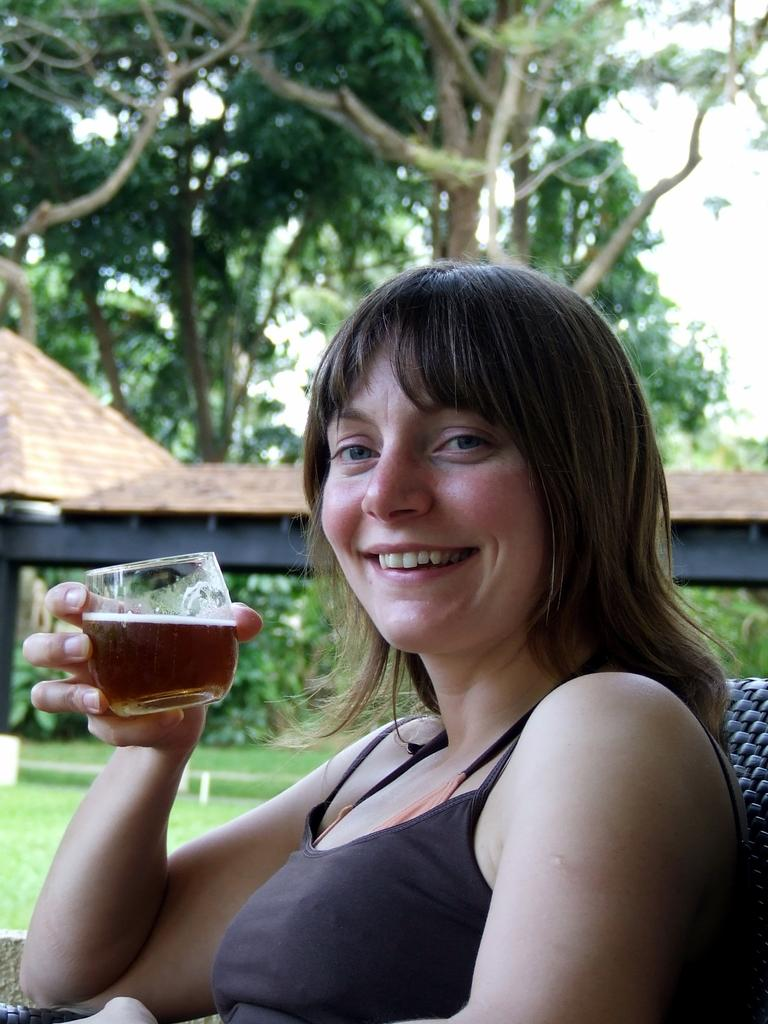Who is the main subject in the image? There is a woman in the image. What is the woman doing in the image? The woman is sitting. What is the woman holding in the image? The woman is holding a glass with a drink in it. What can be seen in the background of the image? There are trees, houses, and grass in the background of the image. What type of picture is the woman holding in the image? There is no picture present in the image; the woman is holding a glass with a drink in it. 